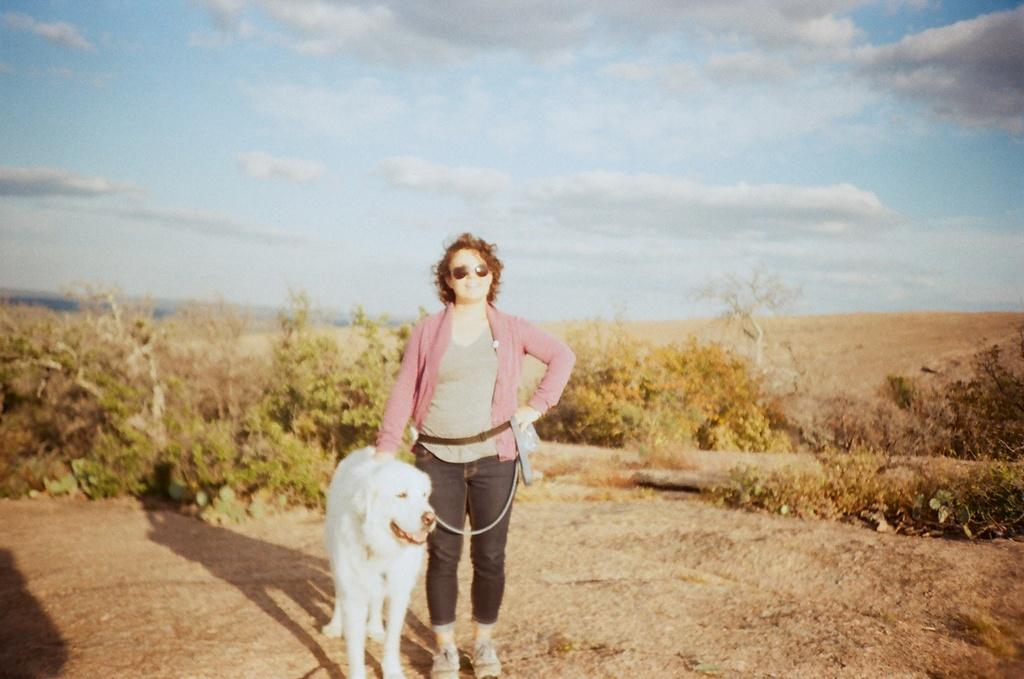What is the woman doing in the image? The woman is standing in the image and holding a dog's leash. What can be seen in the background of the image? There is a tree and the sky visible in the background of the image. What type of prison can be seen in the image? There is no prison present in the image. How does the woman generate heat in the image? The image does not provide any information about the woman generating heat. 